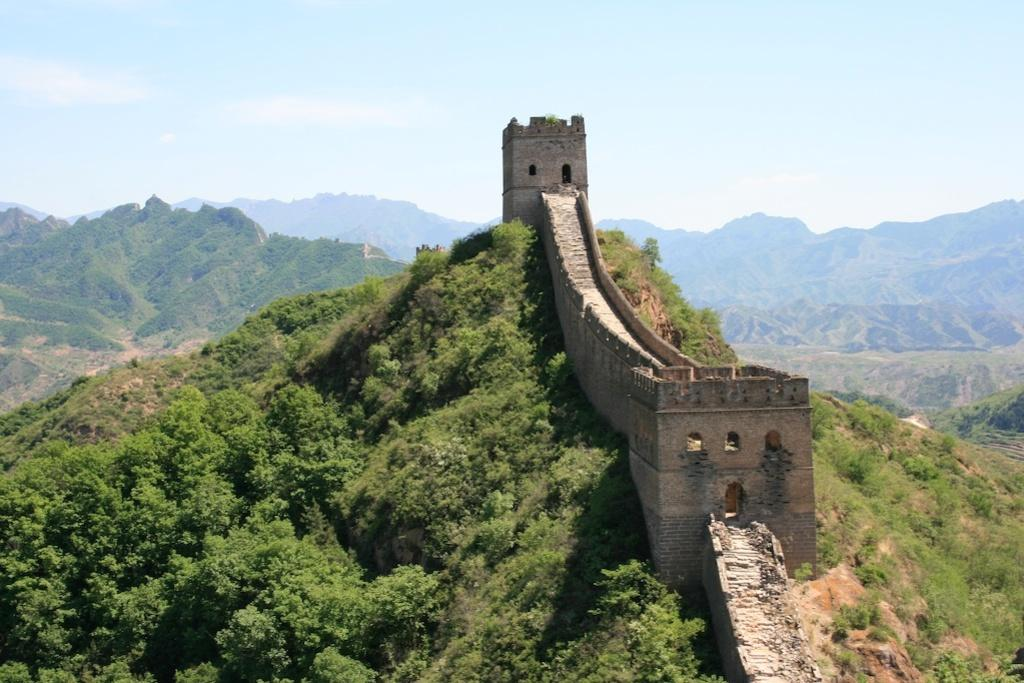What famous landmark can be seen in the image? The Great Wall of China is visible in the image. What type of natural features are present in the image? There are trees and mountains in the image. What is visible in the background of the image? The sky is visible in the background of the image. What type of screw can be seen holding the doll in the image? There is no screw or doll present in the image; it features the Great Wall of China, trees, mountains, and the sky. 